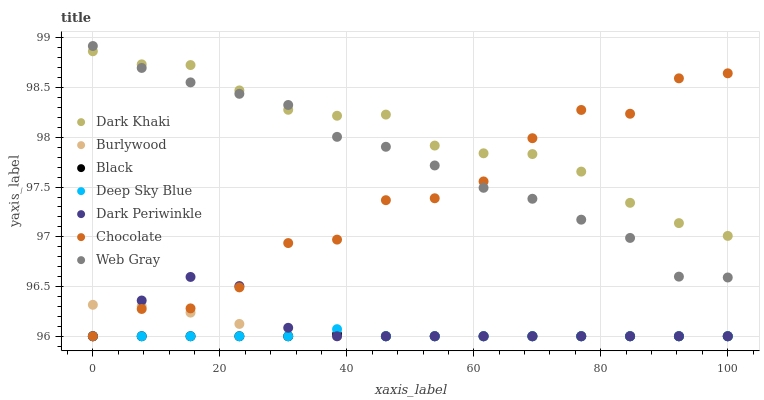Does Black have the minimum area under the curve?
Answer yes or no. Yes. Does Dark Khaki have the maximum area under the curve?
Answer yes or no. Yes. Does Burlywood have the minimum area under the curve?
Answer yes or no. No. Does Burlywood have the maximum area under the curve?
Answer yes or no. No. Is Black the smoothest?
Answer yes or no. Yes. Is Chocolate the roughest?
Answer yes or no. Yes. Is Burlywood the smoothest?
Answer yes or no. No. Is Burlywood the roughest?
Answer yes or no. No. Does Burlywood have the lowest value?
Answer yes or no. Yes. Does Dark Khaki have the lowest value?
Answer yes or no. No. Does Web Gray have the highest value?
Answer yes or no. Yes. Does Burlywood have the highest value?
Answer yes or no. No. Is Black less than Dark Khaki?
Answer yes or no. Yes. Is Dark Khaki greater than Deep Sky Blue?
Answer yes or no. Yes. Does Dark Khaki intersect Chocolate?
Answer yes or no. Yes. Is Dark Khaki less than Chocolate?
Answer yes or no. No. Is Dark Khaki greater than Chocolate?
Answer yes or no. No. Does Black intersect Dark Khaki?
Answer yes or no. No. 